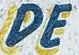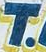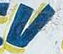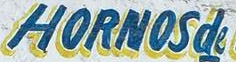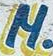Read the text from these images in sequence, separated by a semicolon. DE; T; V; HORNOSde; M 